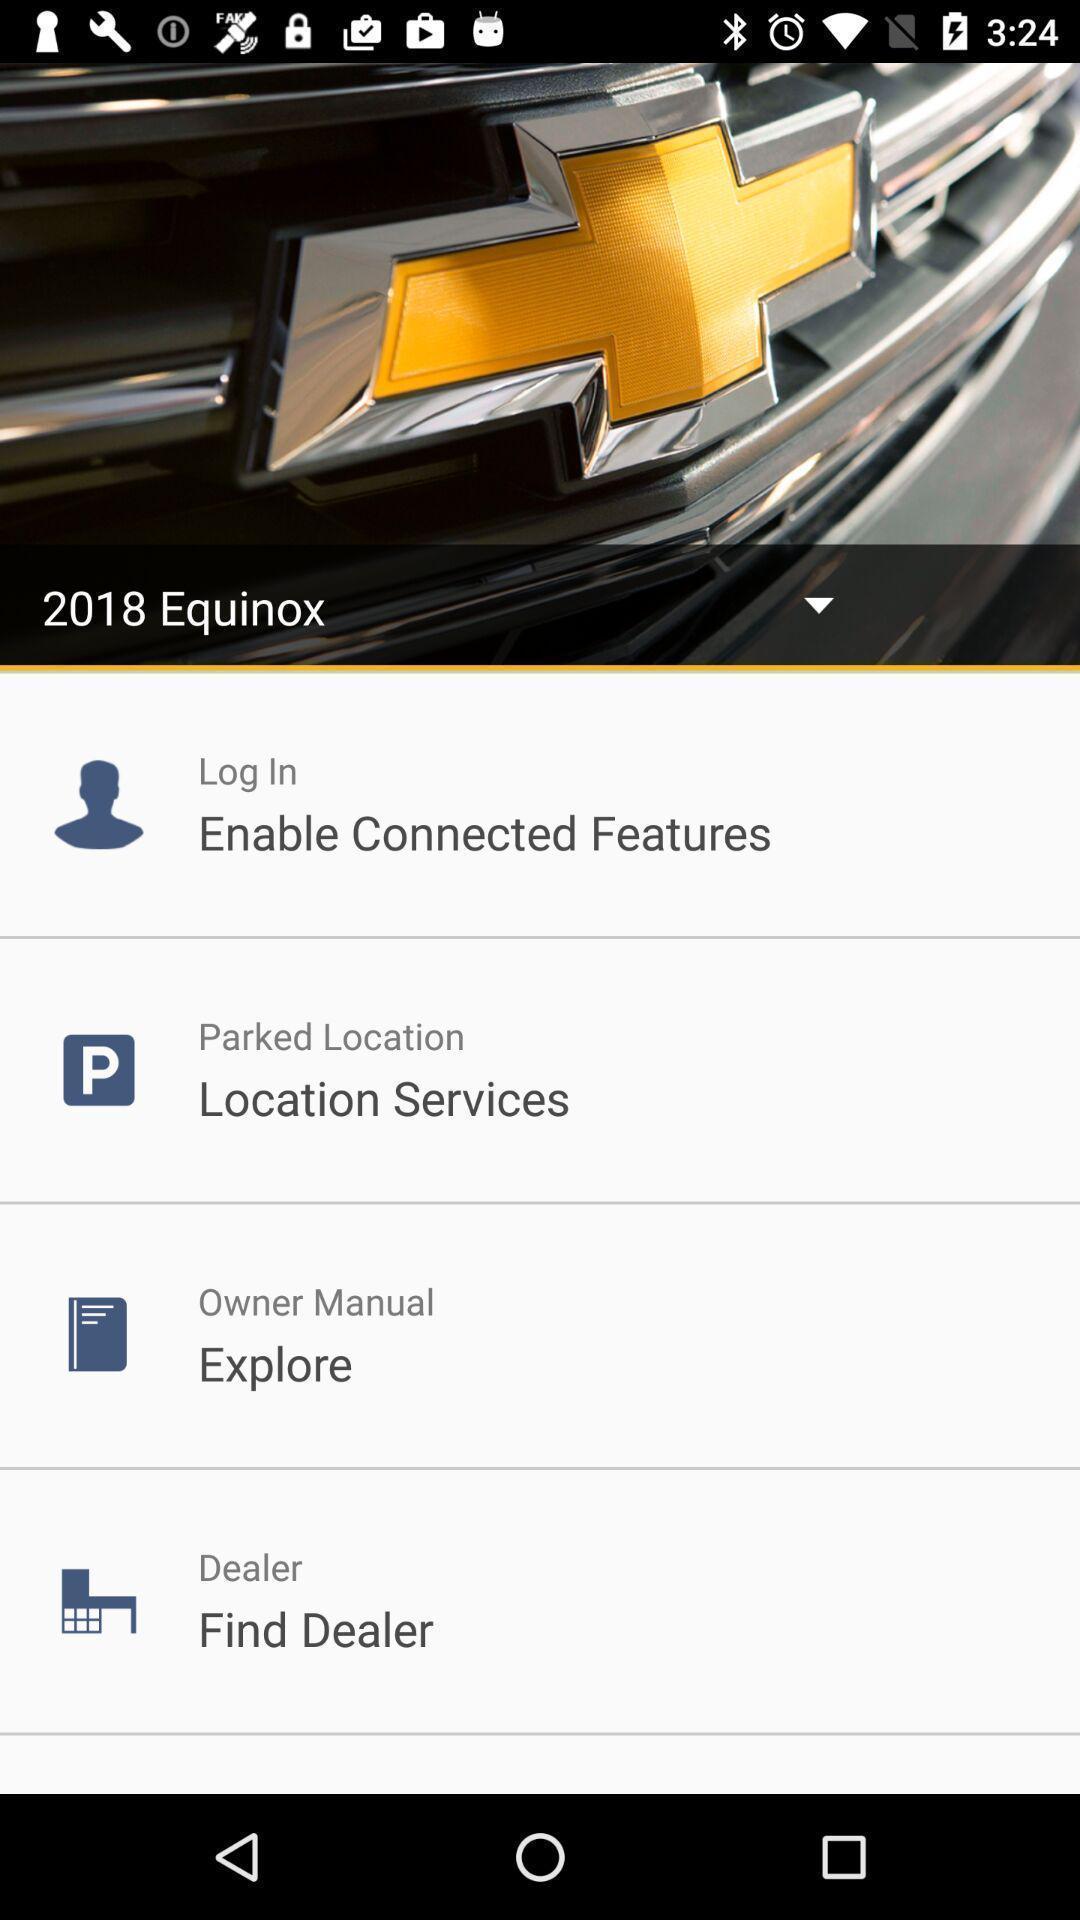What is the overall content of this screenshot? Screen showing options. 